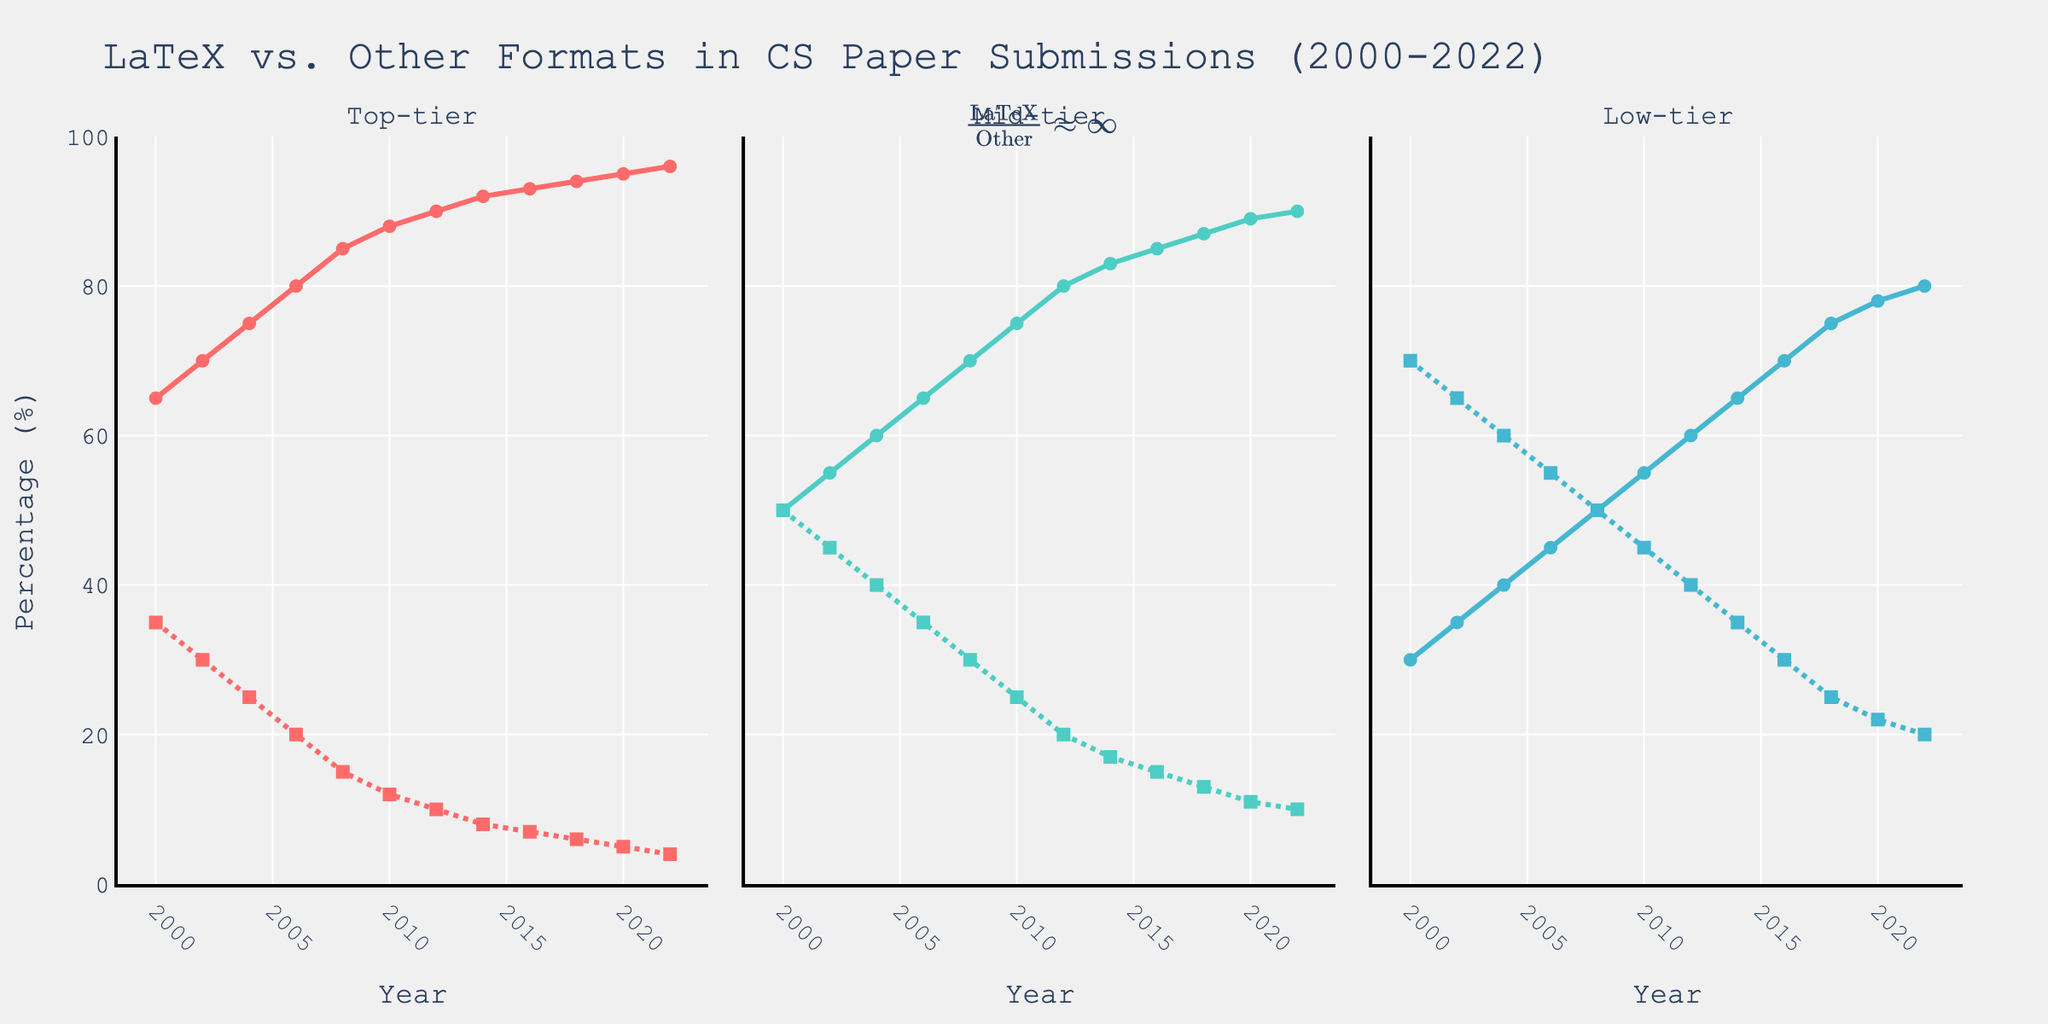What is the percentage difference between Top-tier LaTeX and Top-tier Other in the year 2022? In the year 2022, the percentage for Top-tier LaTeX is 96% and for Top-tier Other is 4%. The difference is 96% - 4% = 92%.
Answer: 92% Between which years did Mid-tier LaTeX see the highest increase in submissions? From the figure, Mid-tier LaTeX submissions rise from 50% in 2000 to 90% in 2022. The most significant year-to-year increase appears between 2010 and 2012, where it goes from 75% to 80%, an increase of 5%.
Answer: 2010 to 2012 Which conference tier saw the largest submission percentage in LaTeX format in 2022? The chart shows that in 2022, Top-tier LaTeX submissions are at 96%, Mid-tier LaTeX at 90%, and Low-tier LaTeX at 80%. Hence, Top-tier has the largest percentage.
Answer: Top-tier By how much did Low-tier LaTeX submissions increase from 2000 to 2010? In 2000, Low-tier LaTeX submissions were at 30%, and in 2010, they were at 55%. The increase is 55% - 30% = 25%.
Answer: 25% What is the visual pattern in the trend of "Other" formats across all conference tiers? The "Other" format submissions in all tiers show a decreasing trend. The dotted lines representing "Other" formats consistently trend downward.
Answer: Decreasing How does the trend of Mid-tier LaTeX submissions compare to Low-tier LaTeX submissions between 2000 and 2022? Both Mid-tier and Low-tier LaTeX submissions have increased over time. However, Mid-tier shows a more rapid increase and has higher percentages in every year compared to Low-tier.
Answer: Mid-tier increased more What percentage of Top-tier submissions were in LaTeX format in the year 2006? According to the chart, the percentage of Top-tier LaTeX submissions in 2006 is 80%.
Answer: 80% What annotation is included in the plot and what does it imply? The annotation in the plot is a LaTeX equation: $\frac{\text{LaTeX}}{\text{Other}} \approx \infty$. It implies that LaTeX submissions dominate over other formats significantly.
Answer: LaTeX dominates Between which years does the Low-tier LaTeX line never cross the 60% mark? The Low-tier LaTeX line stays below 60% from 2000 to 2012, reaching exactly 60% in 2012.
Answer: 2000 to 2012 From which year did all tiers have LaTeX submissions over 50%? All tiers crossed the 50% mark for LaTeX submissions by 2008. Both Mid-tier and Low-tier were at or above 50% in that year.
Answer: 2008 